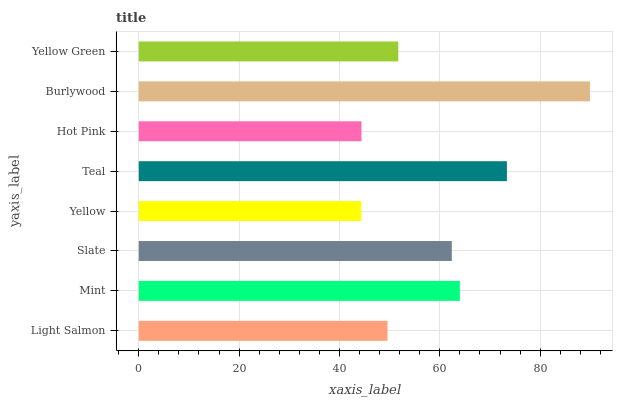Is Yellow the minimum?
Answer yes or no. Yes. Is Burlywood the maximum?
Answer yes or no. Yes. Is Mint the minimum?
Answer yes or no. No. Is Mint the maximum?
Answer yes or no. No. Is Mint greater than Light Salmon?
Answer yes or no. Yes. Is Light Salmon less than Mint?
Answer yes or no. Yes. Is Light Salmon greater than Mint?
Answer yes or no. No. Is Mint less than Light Salmon?
Answer yes or no. No. Is Slate the high median?
Answer yes or no. Yes. Is Yellow Green the low median?
Answer yes or no. Yes. Is Hot Pink the high median?
Answer yes or no. No. Is Slate the low median?
Answer yes or no. No. 